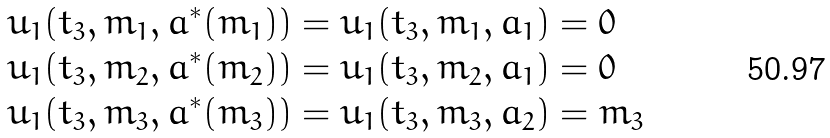<formula> <loc_0><loc_0><loc_500><loc_500>& u _ { 1 } ( t _ { 3 } , m _ { 1 } , a ^ { * } ( m _ { 1 } ) ) = u _ { 1 } ( t _ { 3 } , m _ { 1 } , a _ { 1 } ) = 0 \\ & u _ { 1 } ( t _ { 3 } , m _ { 2 } , a ^ { * } ( m _ { 2 } ) ) = u _ { 1 } ( t _ { 3 } , m _ { 2 } , a _ { 1 } ) = 0 \\ & u _ { 1 } ( t _ { 3 } , m _ { 3 } , a ^ { * } ( m _ { 3 } ) ) = u _ { 1 } ( t _ { 3 } , m _ { 3 } , a _ { 2 } ) = m _ { 3 }</formula> 